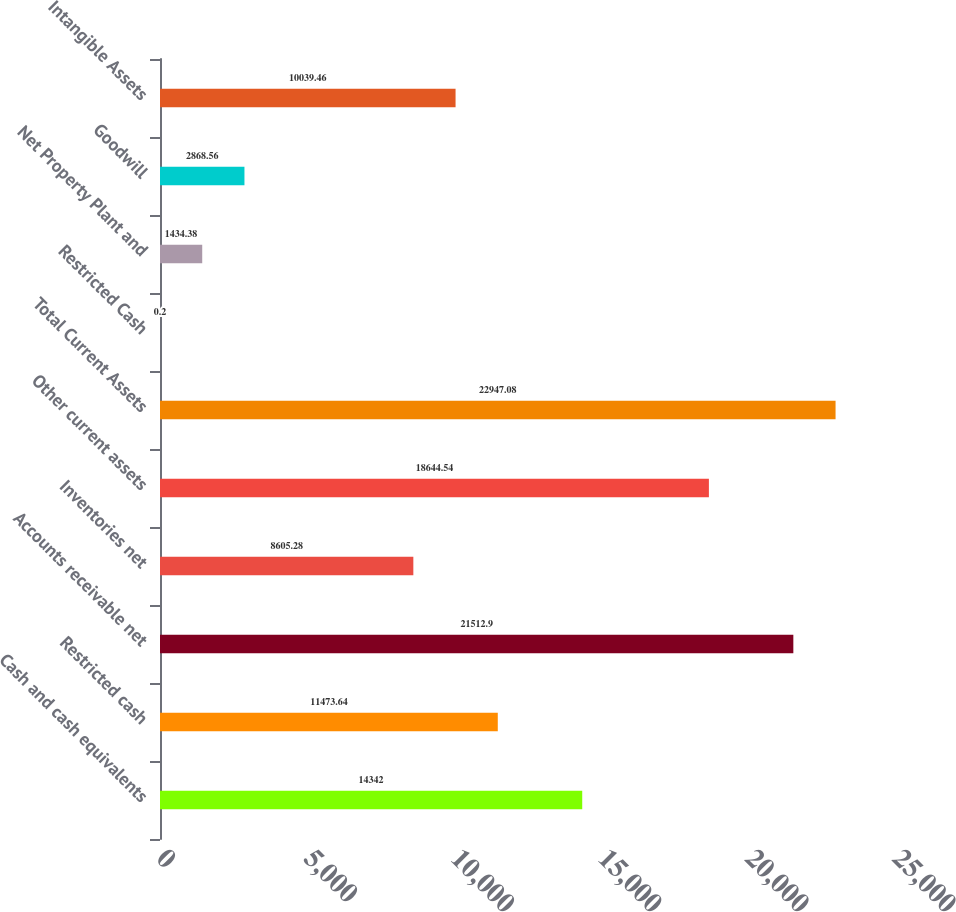<chart> <loc_0><loc_0><loc_500><loc_500><bar_chart><fcel>Cash and cash equivalents<fcel>Restricted cash<fcel>Accounts receivable net<fcel>Inventories net<fcel>Other current assets<fcel>Total Current Assets<fcel>Restricted Cash<fcel>Net Property Plant and<fcel>Goodwill<fcel>Intangible Assets<nl><fcel>14342<fcel>11473.6<fcel>21512.9<fcel>8605.28<fcel>18644.5<fcel>22947.1<fcel>0.2<fcel>1434.38<fcel>2868.56<fcel>10039.5<nl></chart> 